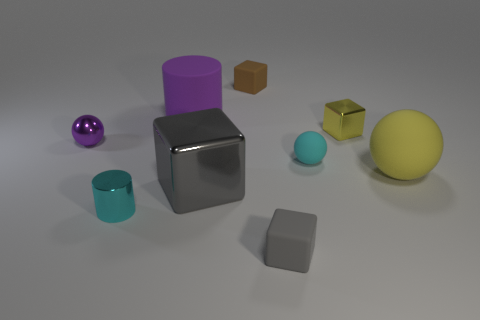Which objects in the image could be used together to form a stable base for a sculpture? The silver cube and the purple cylinder, with their flat surfaces, could serve as a stable base for a sculpture. Their ample volume and flat surfaces increase stability, making them ideal for supporting additional elements in a composition. 